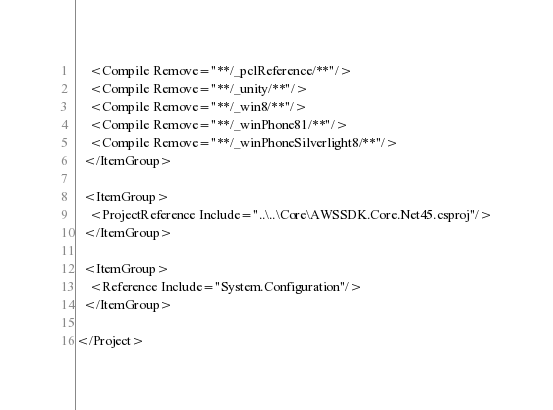Convert code to text. <code><loc_0><loc_0><loc_500><loc_500><_XML_>    <Compile Remove="**/_pclReference/**"/>
    <Compile Remove="**/_unity/**"/>
    <Compile Remove="**/_win8/**"/>
    <Compile Remove="**/_winPhone81/**"/>
    <Compile Remove="**/_winPhoneSilverlight8/**"/>
  </ItemGroup>

  <ItemGroup>
    <ProjectReference Include="..\..\Core\AWSSDK.Core.Net45.csproj"/>
  </ItemGroup>

  <ItemGroup>
    <Reference Include="System.Configuration"/>
  </ItemGroup>

</Project></code> 